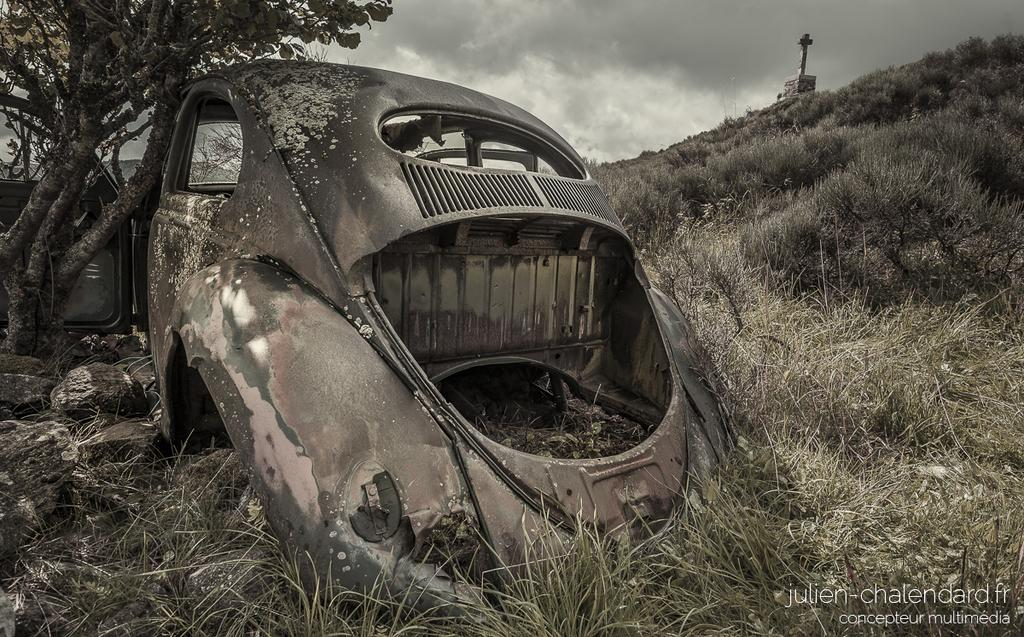What is the main subject of the image? There is a scrapped vehicle in the image. What can be seen around the vehicle? There is a lot of grass around the vehicle. What is visible behind the vehicle? There is a tree behind the vehicle. How many cattle can be seen grazing in the grass near the vehicle? There are no cattle visible in the image; it only shows a scrapped vehicle, grass, and a tree. 